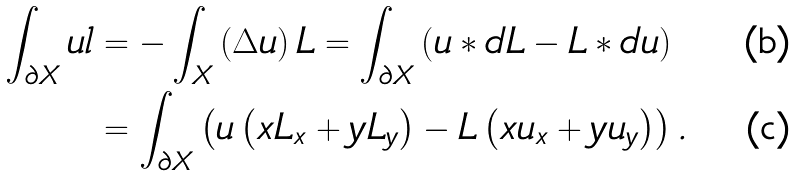<formula> <loc_0><loc_0><loc_500><loc_500>\int _ { \partial X } u l & = - \int _ { X } \left ( \Delta u \right ) L = \int _ { \partial X } \left ( u \ast d L - L \ast d u \right ) \\ & = \int _ { \partial X } \left ( u \left ( x L _ { x } + y L _ { y } \right ) - L \left ( x u _ { x } + y u _ { y } \right ) \right ) .</formula> 